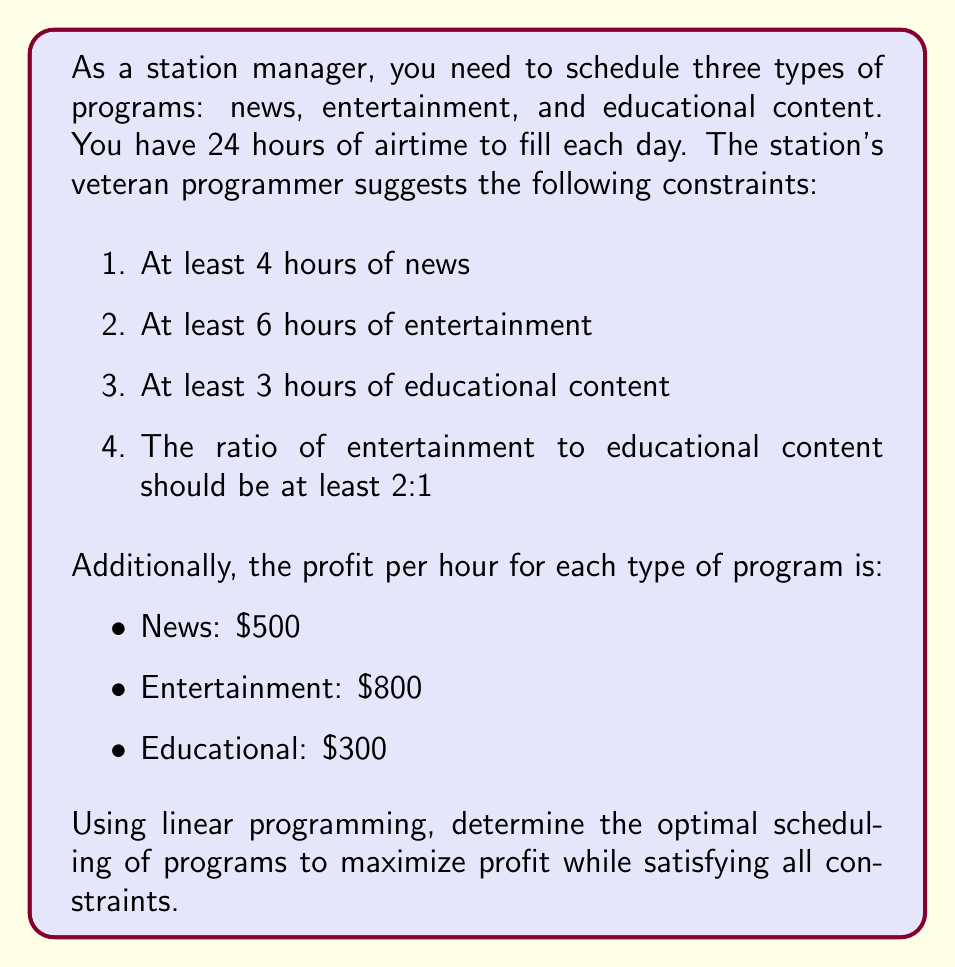Show me your answer to this math problem. Let's approach this problem step-by-step using linear programming:

1. Define variables:
   Let $x$ = hours of news
       $y$ = hours of entertainment
       $z$ = hours of educational content

2. Objective function (maximize profit):
   $\text{Maximize } P = 500x + 800y + 300z$

3. Constraints:
   a) Total airtime: $x + y + z = 24$
   b) Minimum news: $x \geq 4$
   c) Minimum entertainment: $y \geq 6$
   d) Minimum educational: $z \geq 3$
   e) Entertainment to educational ratio: $y \geq 2z$
   f) Non-negativity: $x, y, z \geq 0$

4. Solve using the simplex method or linear programming software.

5. The optimal solution is:
   $x = 4$ (news)
   $y = 14$ (entertainment)
   $z = 6$ (educational)

6. Verify constraints:
   a) $4 + 14 + 6 = 24$ (satisfied)
   b) $4 \geq 4$ (satisfied)
   c) $14 \geq 6$ (satisfied)
   d) $6 \geq 3$ (satisfied)
   e) $14 \geq 2(6)$ (satisfied)

7. Calculate maximum profit:
   $P = 500(4) + 800(14) + 300(6) = 15,000$

Therefore, the optimal scheduling that maximizes profit while satisfying all constraints is 4 hours of news, 14 hours of entertainment, and 6 hours of educational content.
Answer: The optimal scheduling is:
- News: 4 hours
- Entertainment: 14 hours
- Educational: 6 hours

Maximum profit: $15,000 per day 